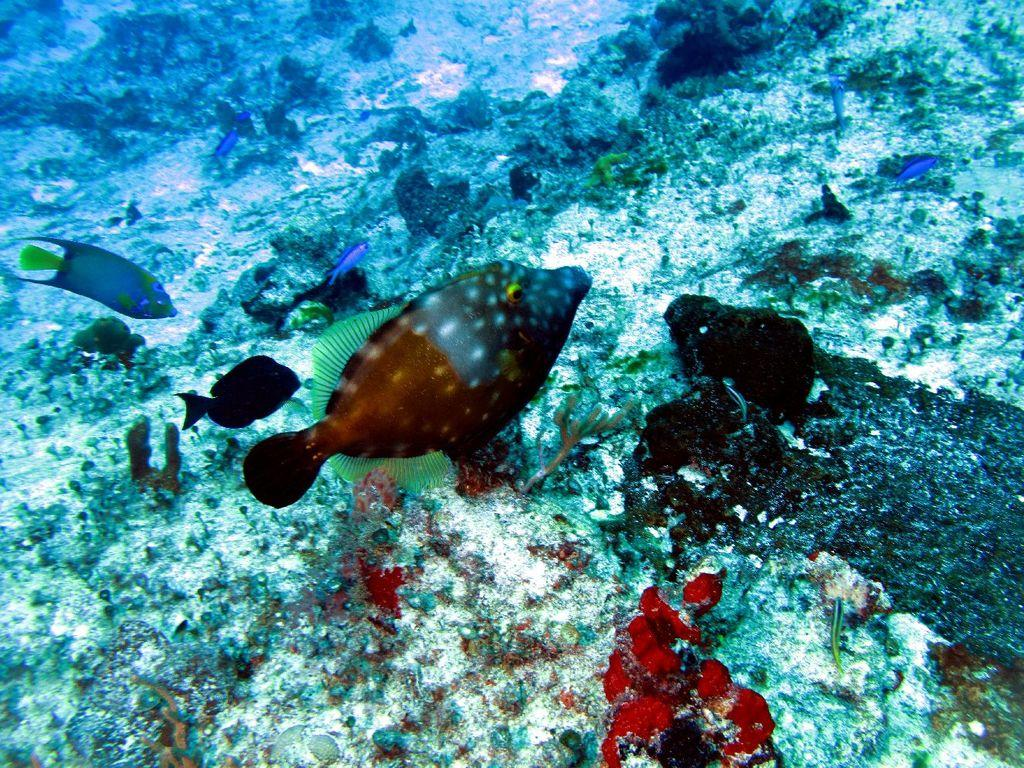What type of animals are in the image? There are fishes in the image. Can you describe the appearance of the fishes? The fishes have different colors. Where are the fishes located in the image? The fishes are located in the middle of the image. What type of magic is the fishes performing in the image? There is no magic or any magical performance involving the fishes in the image. What song are the fishes singing in the image? There is no indication that the fishes are singing a song in the image. 